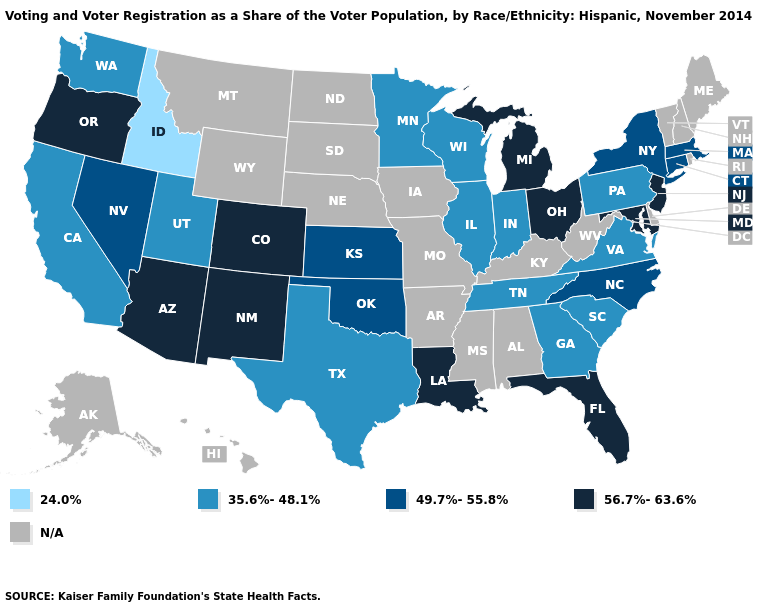What is the value of Rhode Island?
Concise answer only. N/A. Which states have the lowest value in the MidWest?
Be succinct. Illinois, Indiana, Minnesota, Wisconsin. Which states have the lowest value in the USA?
Keep it brief. Idaho. Does California have the highest value in the USA?
Give a very brief answer. No. Name the states that have a value in the range 35.6%-48.1%?
Concise answer only. California, Georgia, Illinois, Indiana, Minnesota, Pennsylvania, South Carolina, Tennessee, Texas, Utah, Virginia, Washington, Wisconsin. Does the map have missing data?
Quick response, please. Yes. Name the states that have a value in the range 24.0%?
Quick response, please. Idaho. Name the states that have a value in the range 35.6%-48.1%?
Short answer required. California, Georgia, Illinois, Indiana, Minnesota, Pennsylvania, South Carolina, Tennessee, Texas, Utah, Virginia, Washington, Wisconsin. Does the first symbol in the legend represent the smallest category?
Quick response, please. Yes. How many symbols are there in the legend?
Be succinct. 5. What is the value of Kansas?
Give a very brief answer. 49.7%-55.8%. Among the states that border Wyoming , does Utah have the lowest value?
Give a very brief answer. No. What is the lowest value in the USA?
Keep it brief. 24.0%. 